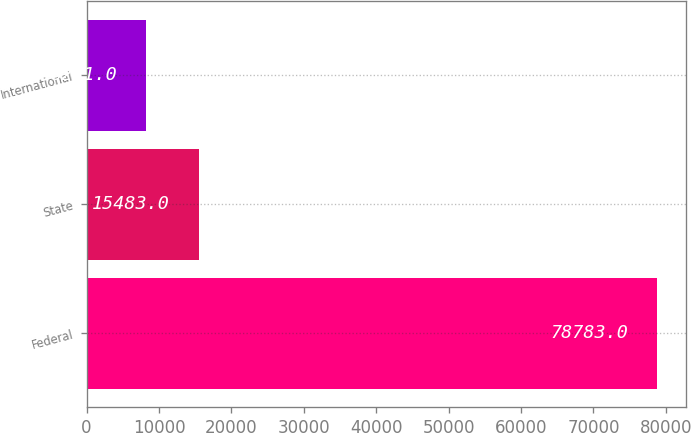Convert chart to OTSL. <chart><loc_0><loc_0><loc_500><loc_500><bar_chart><fcel>Federal<fcel>State<fcel>International<nl><fcel>78783<fcel>15483<fcel>8231<nl></chart> 